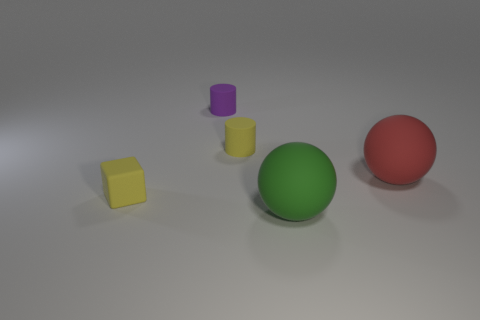Add 1 small purple objects. How many objects exist? 6 Subtract all cylinders. How many objects are left? 3 Subtract all large yellow matte cylinders. Subtract all cylinders. How many objects are left? 3 Add 2 large green balls. How many large green balls are left? 3 Add 5 matte things. How many matte things exist? 10 Subtract 0 purple balls. How many objects are left? 5 